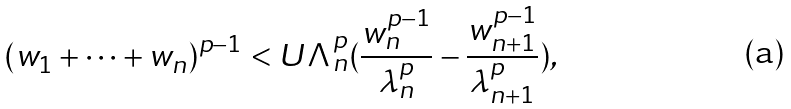Convert formula to latex. <formula><loc_0><loc_0><loc_500><loc_500>( w _ { 1 } + \cdots + w _ { n } ) ^ { p - 1 } < U \Lambda ^ { p } _ { n } ( \frac { w _ { n } ^ { p - 1 } } { \lambda ^ { p } _ { n } } - \frac { w _ { n + 1 } ^ { p - 1 } } { \lambda ^ { p } _ { n + 1 } } ) ,</formula> 